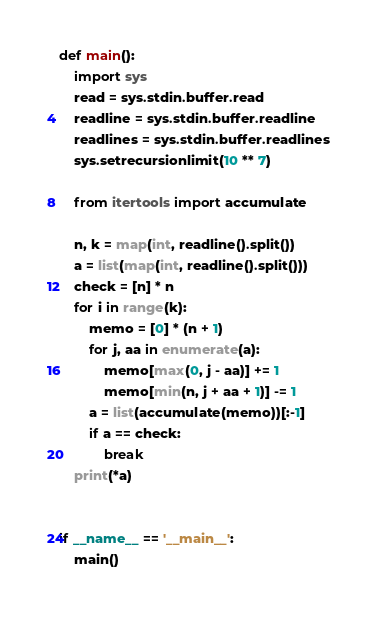<code> <loc_0><loc_0><loc_500><loc_500><_Python_>def main():
    import sys
    read = sys.stdin.buffer.read
    readline = sys.stdin.buffer.readline
    readlines = sys.stdin.buffer.readlines
    sys.setrecursionlimit(10 ** 7)
    
    from itertools import accumulate

    n, k = map(int, readline().split())
    a = list(map(int, readline().split()))
    check = [n] * n
    for i in range(k):
        memo = [0] * (n + 1)
        for j, aa in enumerate(a):
            memo[max(0, j - aa)] += 1
            memo[min(n, j + aa + 1)] -= 1
        a = list(accumulate(memo))[:-1]
        if a == check:
            break
    print(*a)


if __name__ == '__main__':
    main()
</code> 